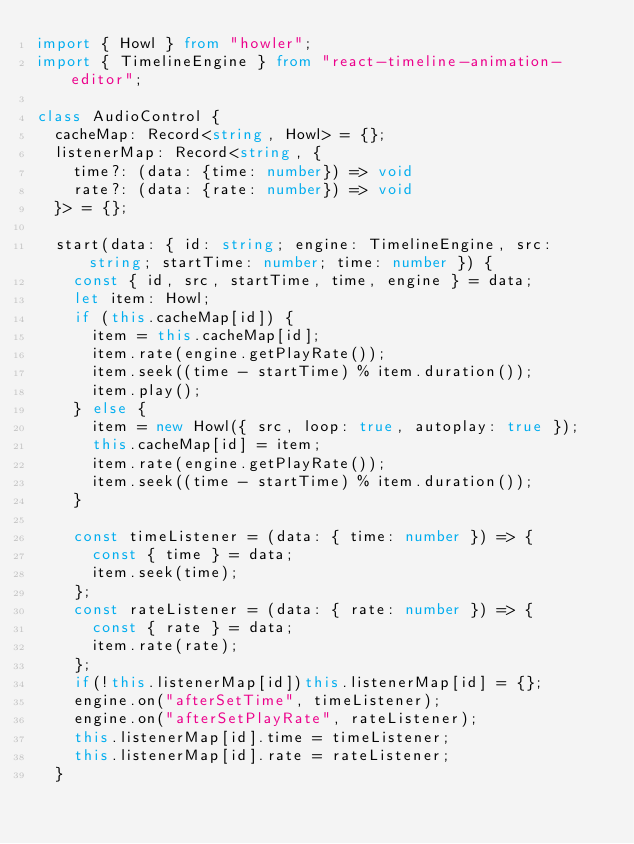Convert code to text. <code><loc_0><loc_0><loc_500><loc_500><_TypeScript_>import { Howl } from "howler";
import { TimelineEngine } from "react-timeline-animation-editor";

class AudioControl {
  cacheMap: Record<string, Howl> = {};
  listenerMap: Record<string, {
    time?: (data: {time: number}) => void
    rate?: (data: {rate: number}) => void
  }> = {};

  start(data: { id: string; engine: TimelineEngine, src: string; startTime: number; time: number }) {
    const { id, src, startTime, time, engine } = data;
    let item: Howl;
    if (this.cacheMap[id]) {
      item = this.cacheMap[id];
      item.rate(engine.getPlayRate());
      item.seek((time - startTime) % item.duration());
      item.play();
    } else {
      item = new Howl({ src, loop: true, autoplay: true });
      this.cacheMap[id] = item;
      item.rate(engine.getPlayRate());
      item.seek((time - startTime) % item.duration());
    }

    const timeListener = (data: { time: number }) => {
      const { time } = data;
      item.seek(time);
    };
    const rateListener = (data: { rate: number }) => {
      const { rate } = data;
      item.rate(rate);
    };
    if(!this.listenerMap[id])this.listenerMap[id] = {};
    engine.on("afterSetTime", timeListener);
    engine.on("afterSetPlayRate", rateListener);
    this.listenerMap[id].time = timeListener;
    this.listenerMap[id].rate = rateListener;
  }
</code> 